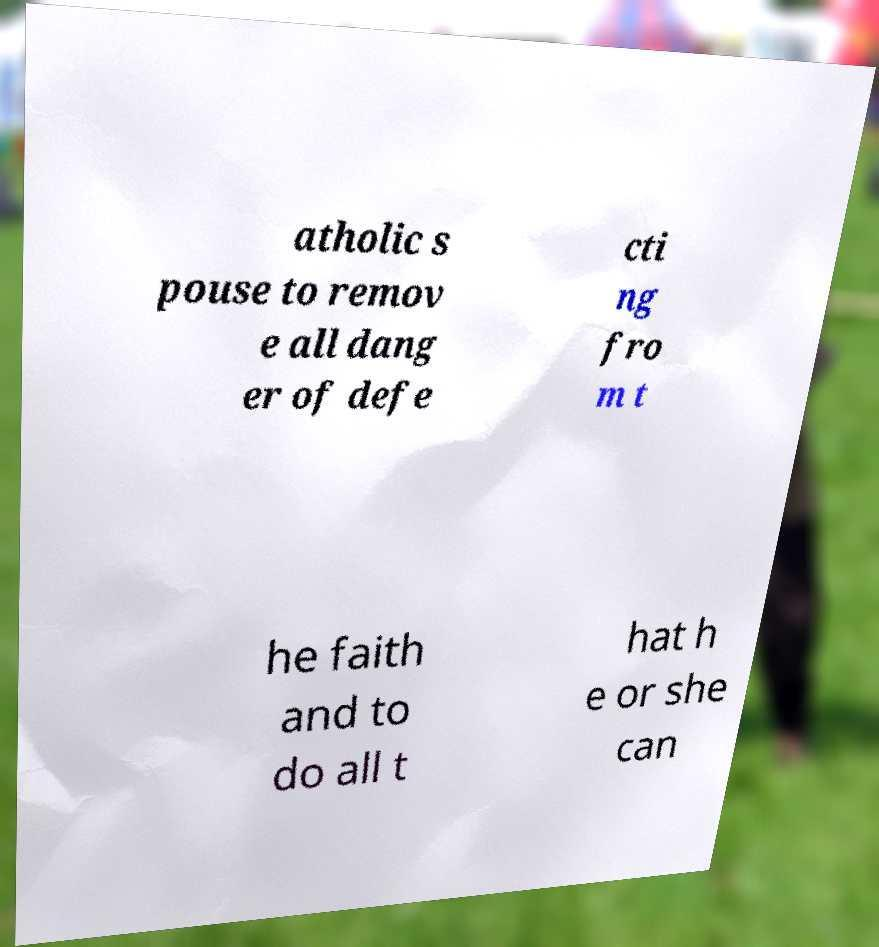Could you assist in decoding the text presented in this image and type it out clearly? atholic s pouse to remov e all dang er of defe cti ng fro m t he faith and to do all t hat h e or she can 